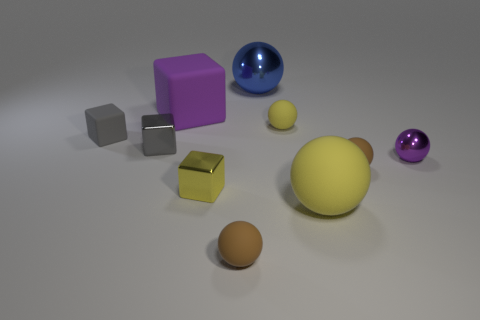Subtract all metallic spheres. How many spheres are left? 4 Subtract all purple blocks. How many blocks are left? 3 Subtract 4 spheres. How many spheres are left? 2 Subtract all brown blocks. Subtract all green cylinders. How many blocks are left? 4 Subtract all balls. How many objects are left? 4 Add 9 red objects. How many red objects exist? 9 Subtract 0 brown cylinders. How many objects are left? 10 Subtract all gray rubber spheres. Subtract all tiny purple metal balls. How many objects are left? 9 Add 1 big objects. How many big objects are left? 4 